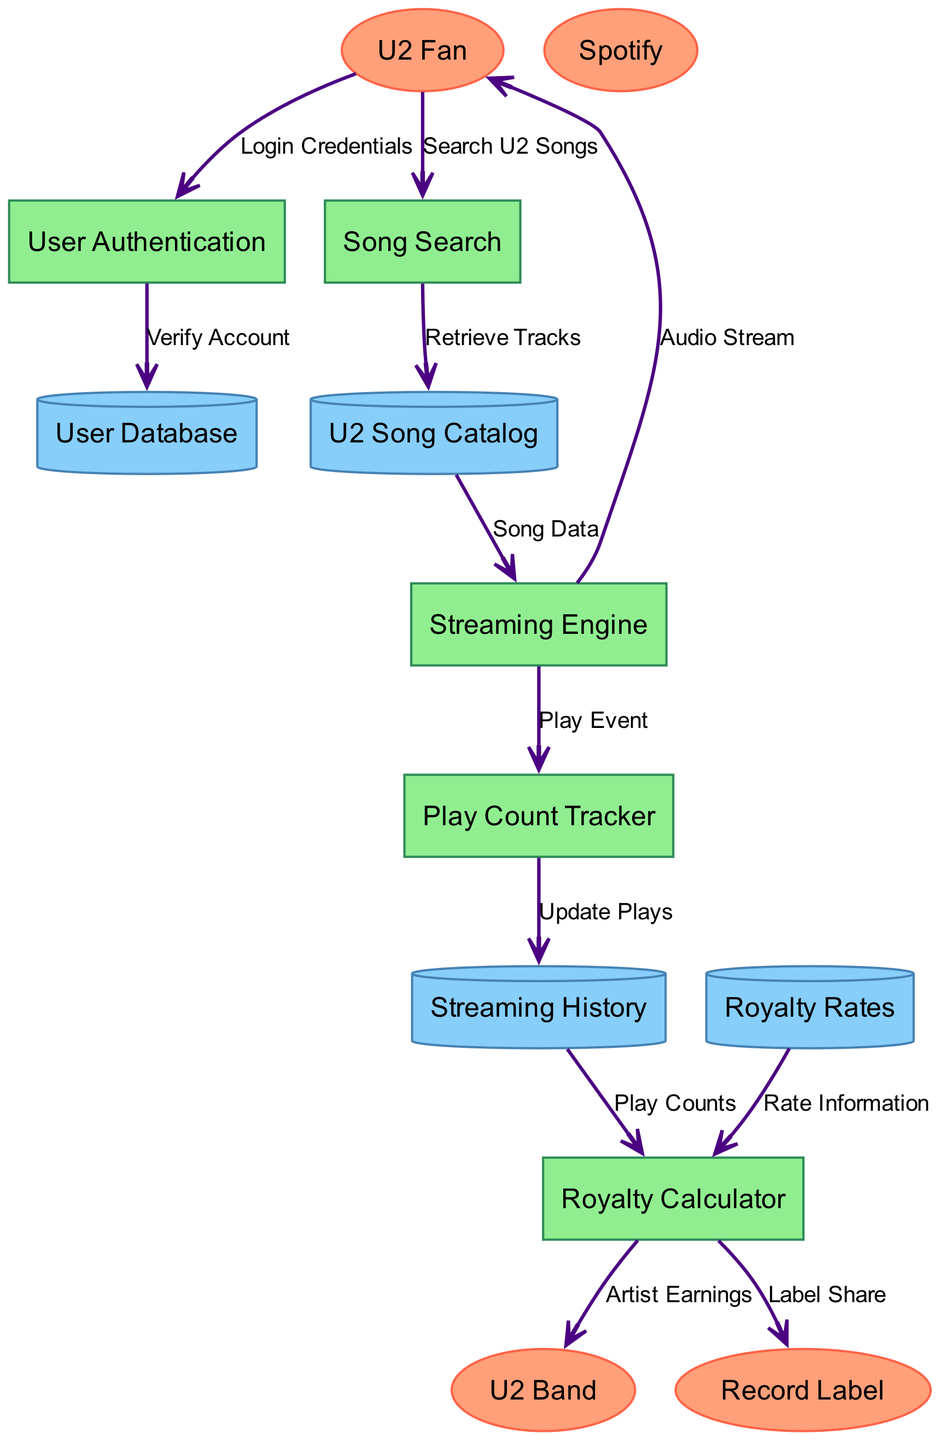What is the first process a U2 fan interacts with? The diagram shows that the first process the U2 fan interacts with is "User Authentication." This can be seen by following the data flow from the external entity "U2 Fan" to the process "User Authentication," which is the first connection.
Answer: User Authentication How many external entities are present in the diagram? The diagram lists four external entities: "U2 Fan," "Spotify," "U2 Band," and "Record Label." Counting these entities provides the answer.
Answer: 4 What data flow connects the Royalty Calculator to the U2 Band? The diagram indicates that the Royalty Calculator sends "Artist Earnings" to the U2 Band. This specific label identifies the connection between these two nodes.
Answer: Artist Earnings Which process receives data from the Song Search process? According to the diagram, the "U2 Song Catalog" is the data store that receives data labeled "Retrieve Tracks" from the "Song Search" process. This flow indicates the relationship.
Answer: U2 Song Catalog What action is tracked by the Play Count Tracker? The "Play Count Tracker" receives "Play Event" information from the "Streaming Engine." This indicates that it tracks play events of U2 songs streamed.
Answer: Play Event Which data flow collects play counts to calculate royalties? The flow from "Streaming History" to "Royalty Calculator" labeled "Play Counts" collects the play counts necessary for calculating royalties. This connection is directly indicated in the diagram.
Answer: Play Counts How many processes are involved in this data flow diagram? The diagram outlines five processes: "User Authentication," "Song Search," "Streaming Engine," "Play Count Tracker," and "Royalty Calculator." Counting these processes yields the answer.
Answer: 5 What does the Royalty Calculator send to the Record Label? The Royalty Calculator sends "Label Share" to the Record Label. The flow connecting these two entities indicates this specific data transfer.
Answer: Label Share What does the Streaming Engine output to the U2 Fan? The output from the Streaming Engine to the U2 fan is "Audio Stream," as indicated by the corresponding data flow in the diagram.
Answer: Audio Stream 